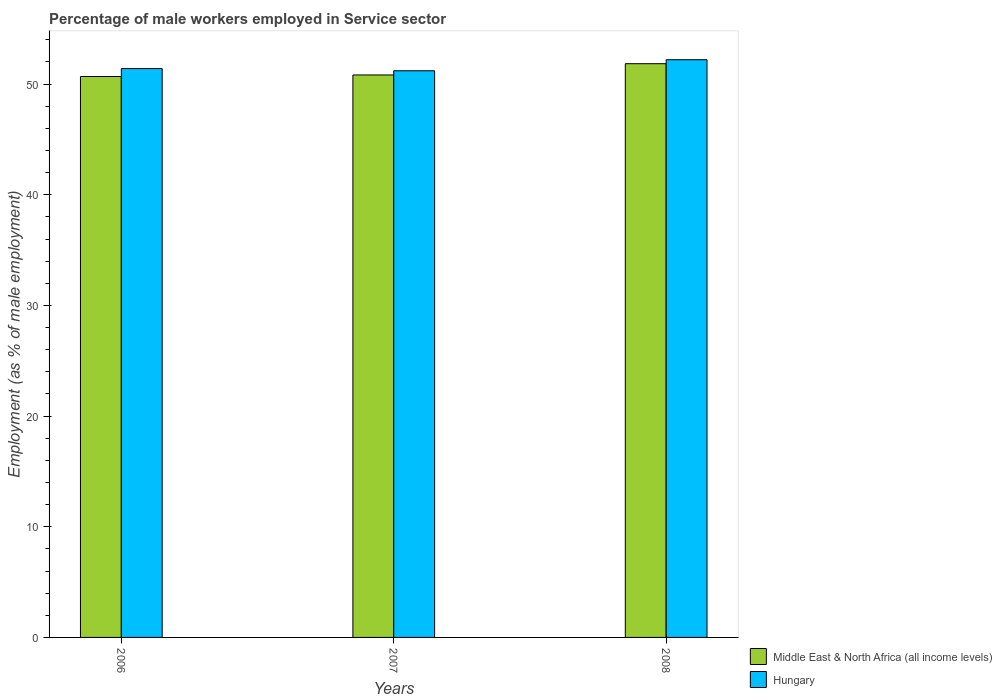How many groups of bars are there?
Your answer should be very brief. 3. Are the number of bars per tick equal to the number of legend labels?
Offer a terse response. Yes. How many bars are there on the 1st tick from the right?
Ensure brevity in your answer.  2. What is the label of the 2nd group of bars from the left?
Your answer should be compact. 2007. What is the percentage of male workers employed in Service sector in Hungary in 2006?
Your response must be concise. 51.4. Across all years, what is the maximum percentage of male workers employed in Service sector in Middle East & North Africa (all income levels)?
Offer a very short reply. 51.84. Across all years, what is the minimum percentage of male workers employed in Service sector in Hungary?
Make the answer very short. 51.2. In which year was the percentage of male workers employed in Service sector in Middle East & North Africa (all income levels) minimum?
Make the answer very short. 2006. What is the total percentage of male workers employed in Service sector in Hungary in the graph?
Your answer should be compact. 154.8. What is the difference between the percentage of male workers employed in Service sector in Middle East & North Africa (all income levels) in 2006 and that in 2008?
Your response must be concise. -1.16. What is the difference between the percentage of male workers employed in Service sector in Hungary in 2007 and the percentage of male workers employed in Service sector in Middle East & North Africa (all income levels) in 2006?
Give a very brief answer. 0.52. What is the average percentage of male workers employed in Service sector in Hungary per year?
Make the answer very short. 51.6. In the year 2007, what is the difference between the percentage of male workers employed in Service sector in Middle East & North Africa (all income levels) and percentage of male workers employed in Service sector in Hungary?
Make the answer very short. -0.38. In how many years, is the percentage of male workers employed in Service sector in Middle East & North Africa (all income levels) greater than 38 %?
Make the answer very short. 3. What is the ratio of the percentage of male workers employed in Service sector in Hungary in 2006 to that in 2008?
Offer a very short reply. 0.98. Is the difference between the percentage of male workers employed in Service sector in Middle East & North Africa (all income levels) in 2006 and 2007 greater than the difference between the percentage of male workers employed in Service sector in Hungary in 2006 and 2007?
Provide a succinct answer. No. What is the difference between the highest and the second highest percentage of male workers employed in Service sector in Hungary?
Your answer should be very brief. 0.8. What is the difference between the highest and the lowest percentage of male workers employed in Service sector in Middle East & North Africa (all income levels)?
Keep it short and to the point. 1.16. Is the sum of the percentage of male workers employed in Service sector in Hungary in 2006 and 2007 greater than the maximum percentage of male workers employed in Service sector in Middle East & North Africa (all income levels) across all years?
Give a very brief answer. Yes. What does the 1st bar from the left in 2007 represents?
Ensure brevity in your answer.  Middle East & North Africa (all income levels). What does the 1st bar from the right in 2007 represents?
Offer a very short reply. Hungary. What is the difference between two consecutive major ticks on the Y-axis?
Make the answer very short. 10. Does the graph contain any zero values?
Your answer should be compact. No. Does the graph contain grids?
Provide a succinct answer. No. How many legend labels are there?
Ensure brevity in your answer.  2. How are the legend labels stacked?
Your answer should be compact. Vertical. What is the title of the graph?
Give a very brief answer. Percentage of male workers employed in Service sector. Does "Poland" appear as one of the legend labels in the graph?
Offer a terse response. No. What is the label or title of the X-axis?
Your response must be concise. Years. What is the label or title of the Y-axis?
Offer a very short reply. Employment (as % of male employment). What is the Employment (as % of male employment) in Middle East & North Africa (all income levels) in 2006?
Your answer should be compact. 50.68. What is the Employment (as % of male employment) in Hungary in 2006?
Make the answer very short. 51.4. What is the Employment (as % of male employment) of Middle East & North Africa (all income levels) in 2007?
Keep it short and to the point. 50.82. What is the Employment (as % of male employment) of Hungary in 2007?
Ensure brevity in your answer.  51.2. What is the Employment (as % of male employment) of Middle East & North Africa (all income levels) in 2008?
Ensure brevity in your answer.  51.84. What is the Employment (as % of male employment) of Hungary in 2008?
Provide a succinct answer. 52.2. Across all years, what is the maximum Employment (as % of male employment) in Middle East & North Africa (all income levels)?
Give a very brief answer. 51.84. Across all years, what is the maximum Employment (as % of male employment) in Hungary?
Your answer should be compact. 52.2. Across all years, what is the minimum Employment (as % of male employment) of Middle East & North Africa (all income levels)?
Your answer should be compact. 50.68. Across all years, what is the minimum Employment (as % of male employment) in Hungary?
Keep it short and to the point. 51.2. What is the total Employment (as % of male employment) in Middle East & North Africa (all income levels) in the graph?
Your response must be concise. 153.34. What is the total Employment (as % of male employment) in Hungary in the graph?
Your response must be concise. 154.8. What is the difference between the Employment (as % of male employment) in Middle East & North Africa (all income levels) in 2006 and that in 2007?
Offer a very short reply. -0.14. What is the difference between the Employment (as % of male employment) in Middle East & North Africa (all income levels) in 2006 and that in 2008?
Keep it short and to the point. -1.16. What is the difference between the Employment (as % of male employment) in Middle East & North Africa (all income levels) in 2007 and that in 2008?
Your answer should be very brief. -1.02. What is the difference between the Employment (as % of male employment) of Middle East & North Africa (all income levels) in 2006 and the Employment (as % of male employment) of Hungary in 2007?
Offer a very short reply. -0.52. What is the difference between the Employment (as % of male employment) of Middle East & North Africa (all income levels) in 2006 and the Employment (as % of male employment) of Hungary in 2008?
Provide a succinct answer. -1.52. What is the difference between the Employment (as % of male employment) in Middle East & North Africa (all income levels) in 2007 and the Employment (as % of male employment) in Hungary in 2008?
Your answer should be very brief. -1.38. What is the average Employment (as % of male employment) of Middle East & North Africa (all income levels) per year?
Provide a succinct answer. 51.11. What is the average Employment (as % of male employment) of Hungary per year?
Offer a terse response. 51.6. In the year 2006, what is the difference between the Employment (as % of male employment) in Middle East & North Africa (all income levels) and Employment (as % of male employment) in Hungary?
Provide a succinct answer. -0.72. In the year 2007, what is the difference between the Employment (as % of male employment) of Middle East & North Africa (all income levels) and Employment (as % of male employment) of Hungary?
Your response must be concise. -0.38. In the year 2008, what is the difference between the Employment (as % of male employment) of Middle East & North Africa (all income levels) and Employment (as % of male employment) of Hungary?
Give a very brief answer. -0.36. What is the ratio of the Employment (as % of male employment) in Middle East & North Africa (all income levels) in 2006 to that in 2008?
Offer a terse response. 0.98. What is the ratio of the Employment (as % of male employment) in Hungary in 2006 to that in 2008?
Offer a very short reply. 0.98. What is the ratio of the Employment (as % of male employment) of Middle East & North Africa (all income levels) in 2007 to that in 2008?
Offer a terse response. 0.98. What is the ratio of the Employment (as % of male employment) in Hungary in 2007 to that in 2008?
Your response must be concise. 0.98. What is the difference between the highest and the second highest Employment (as % of male employment) of Middle East & North Africa (all income levels)?
Provide a succinct answer. 1.02. What is the difference between the highest and the second highest Employment (as % of male employment) in Hungary?
Keep it short and to the point. 0.8. What is the difference between the highest and the lowest Employment (as % of male employment) in Middle East & North Africa (all income levels)?
Your response must be concise. 1.16. 